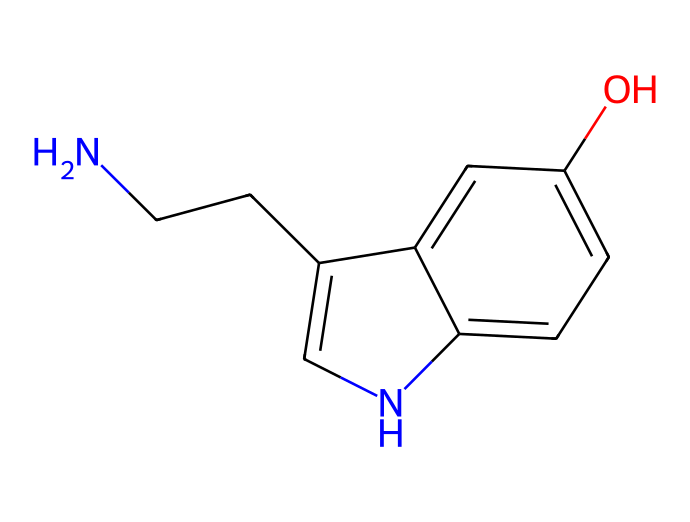What is the molecular formula of serotonin? To find the molecular formula, we need to count the atoms for each element in the SMILES representation. The breakdown is: 10 Carbon (C), 12 Hydrogen (H), 1 Nitrogen (N), and 1 Oxygen (O). Thus, the molecular formula is C10H12N2O.
Answer: C10H12N2O How many rings are present in serotonin's structure? By examining the structure, we can identify that there are two interconnected rings, one is the benzene ring (six-membered) and the other is an indole structure which includes an additional five-membered ring. Therefore, there are 2 rings in total.
Answer: 2 What type of functional groups are present in serotonin? Looking at the SMILES, we notice an -OH (hydroxyl) group and an amine group (the nitrogen connected to carbon). This indicates that serotonin contains both a hydroxyl and an amine functional group.
Answer: hydroxyl and amine Is serotonin a polar or non-polar molecule? Considering that serotonin contains a hydroxyl group and an amine group, which can form hydrogen bonds with water, it's clear that it’s polar. The presence of these polar functional groups significantly contributes to its solubility in water.
Answer: polar What role does serotonin play in the human body? Serotonin is commonly known to regulate mood and is often referred to as the "happy hormone." It is crucial for mood stabilization, as well as regulating feelings of happiness and well-being in the body.
Answer: mood regulation 